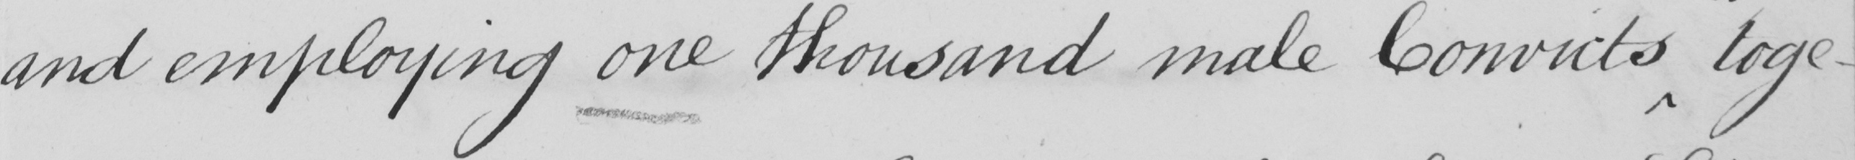What is written in this line of handwriting? and employing one thousand male Convicts toge- 